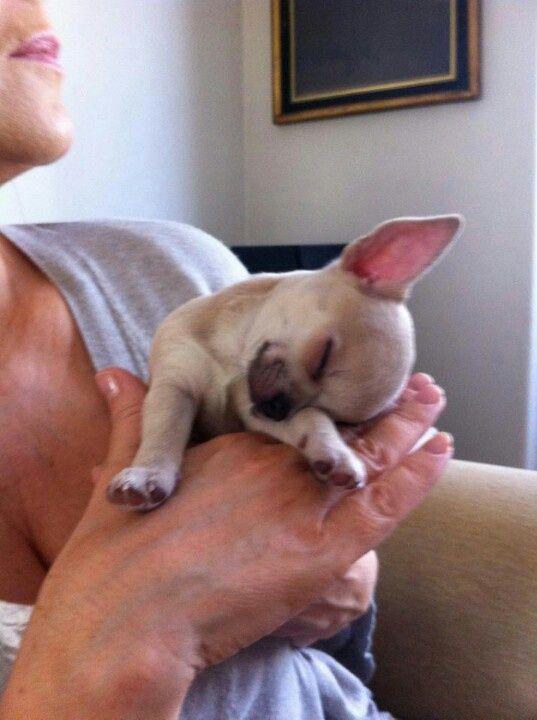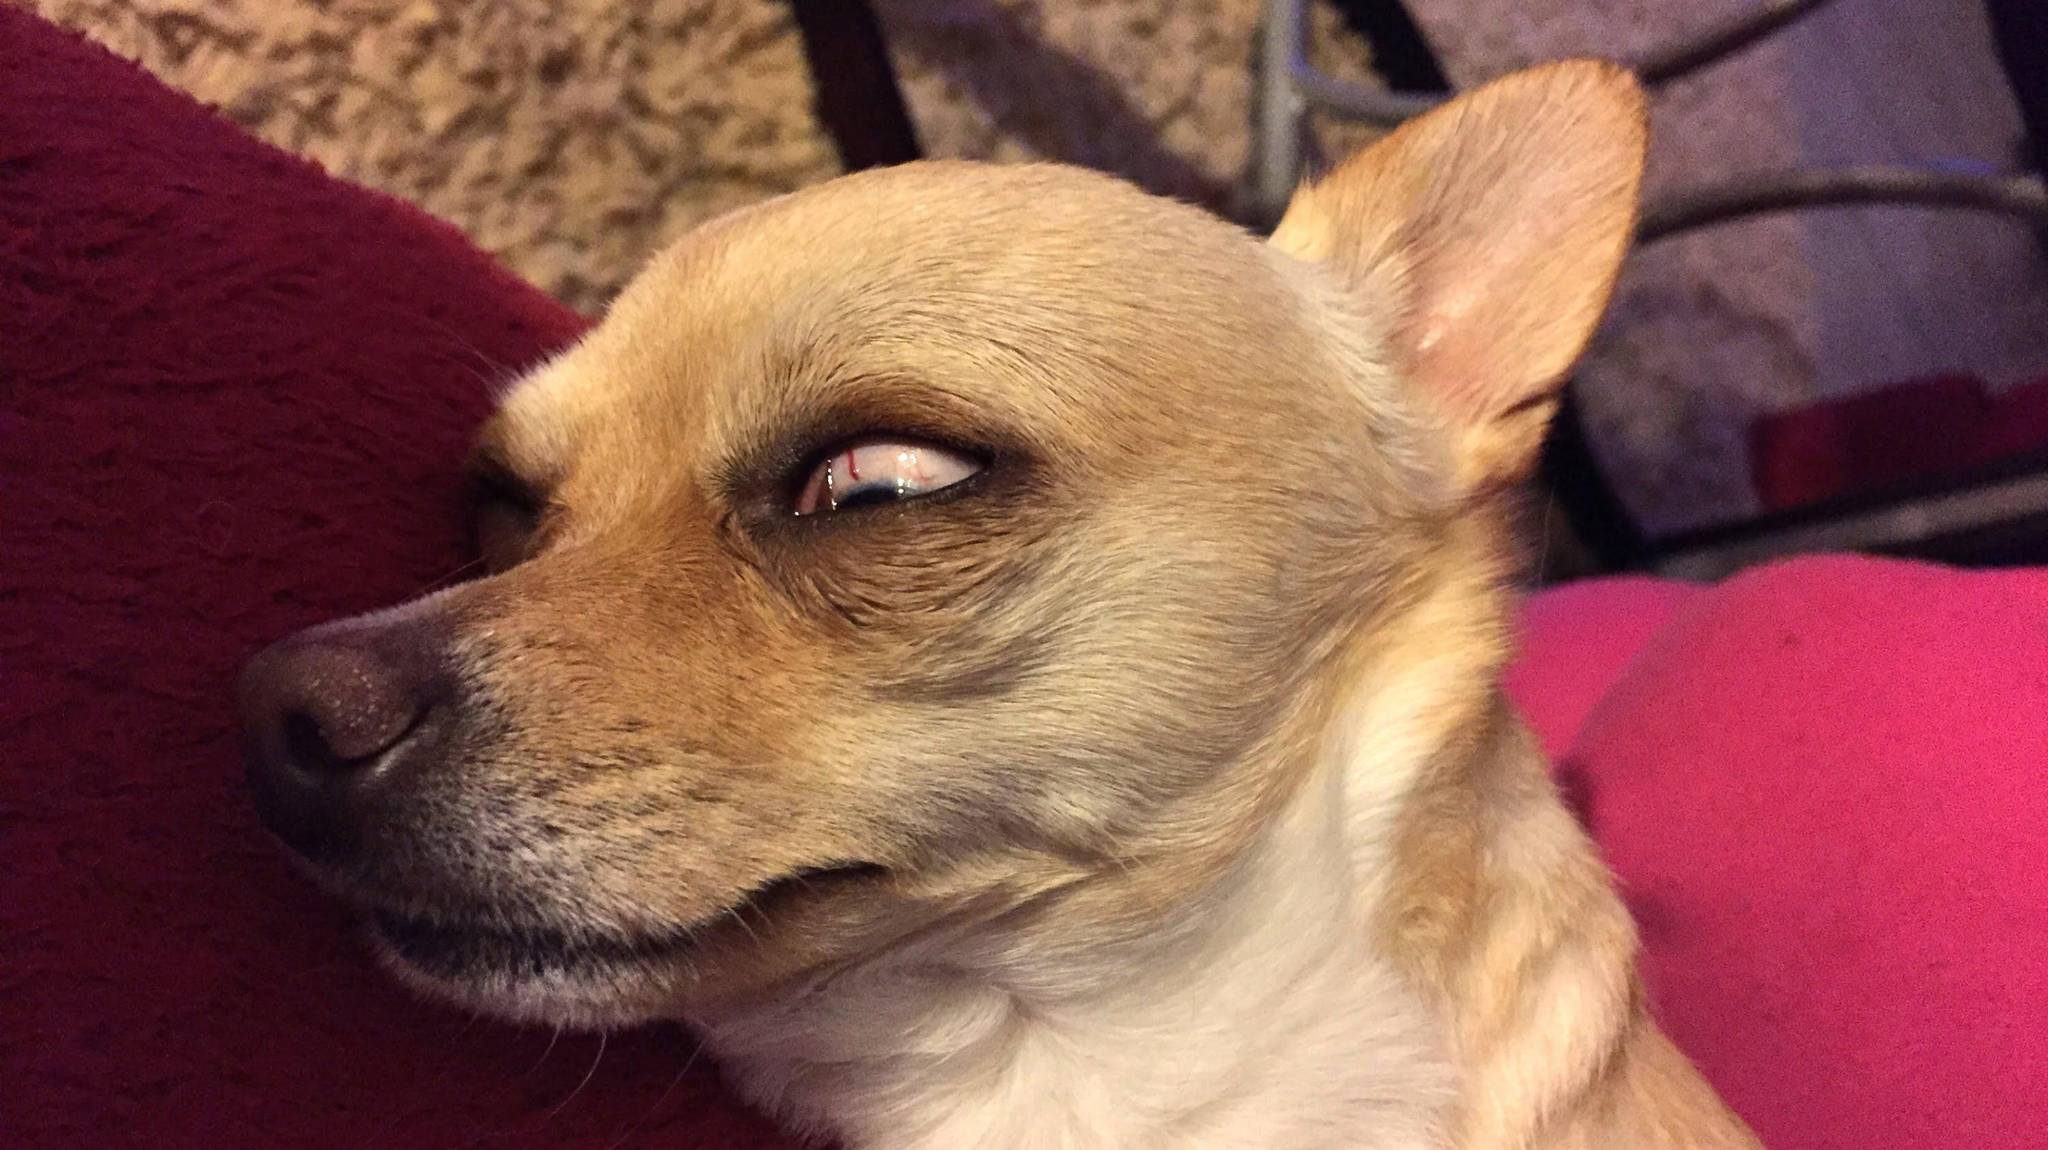The first image is the image on the left, the second image is the image on the right. For the images displayed, is the sentence "The eyes of the dog in the image on the right are half open." factually correct? Answer yes or no. Yes. 